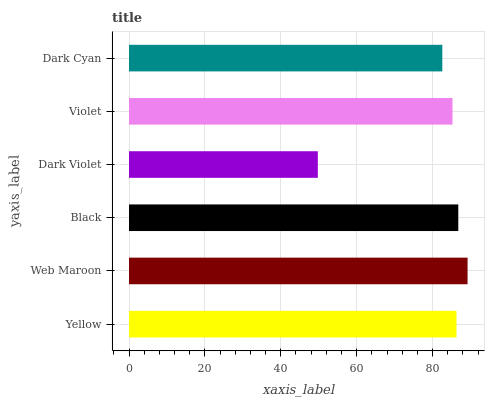Is Dark Violet the minimum?
Answer yes or no. Yes. Is Web Maroon the maximum?
Answer yes or no. Yes. Is Black the minimum?
Answer yes or no. No. Is Black the maximum?
Answer yes or no. No. Is Web Maroon greater than Black?
Answer yes or no. Yes. Is Black less than Web Maroon?
Answer yes or no. Yes. Is Black greater than Web Maroon?
Answer yes or no. No. Is Web Maroon less than Black?
Answer yes or no. No. Is Yellow the high median?
Answer yes or no. Yes. Is Violet the low median?
Answer yes or no. Yes. Is Web Maroon the high median?
Answer yes or no. No. Is Dark Cyan the low median?
Answer yes or no. No. 